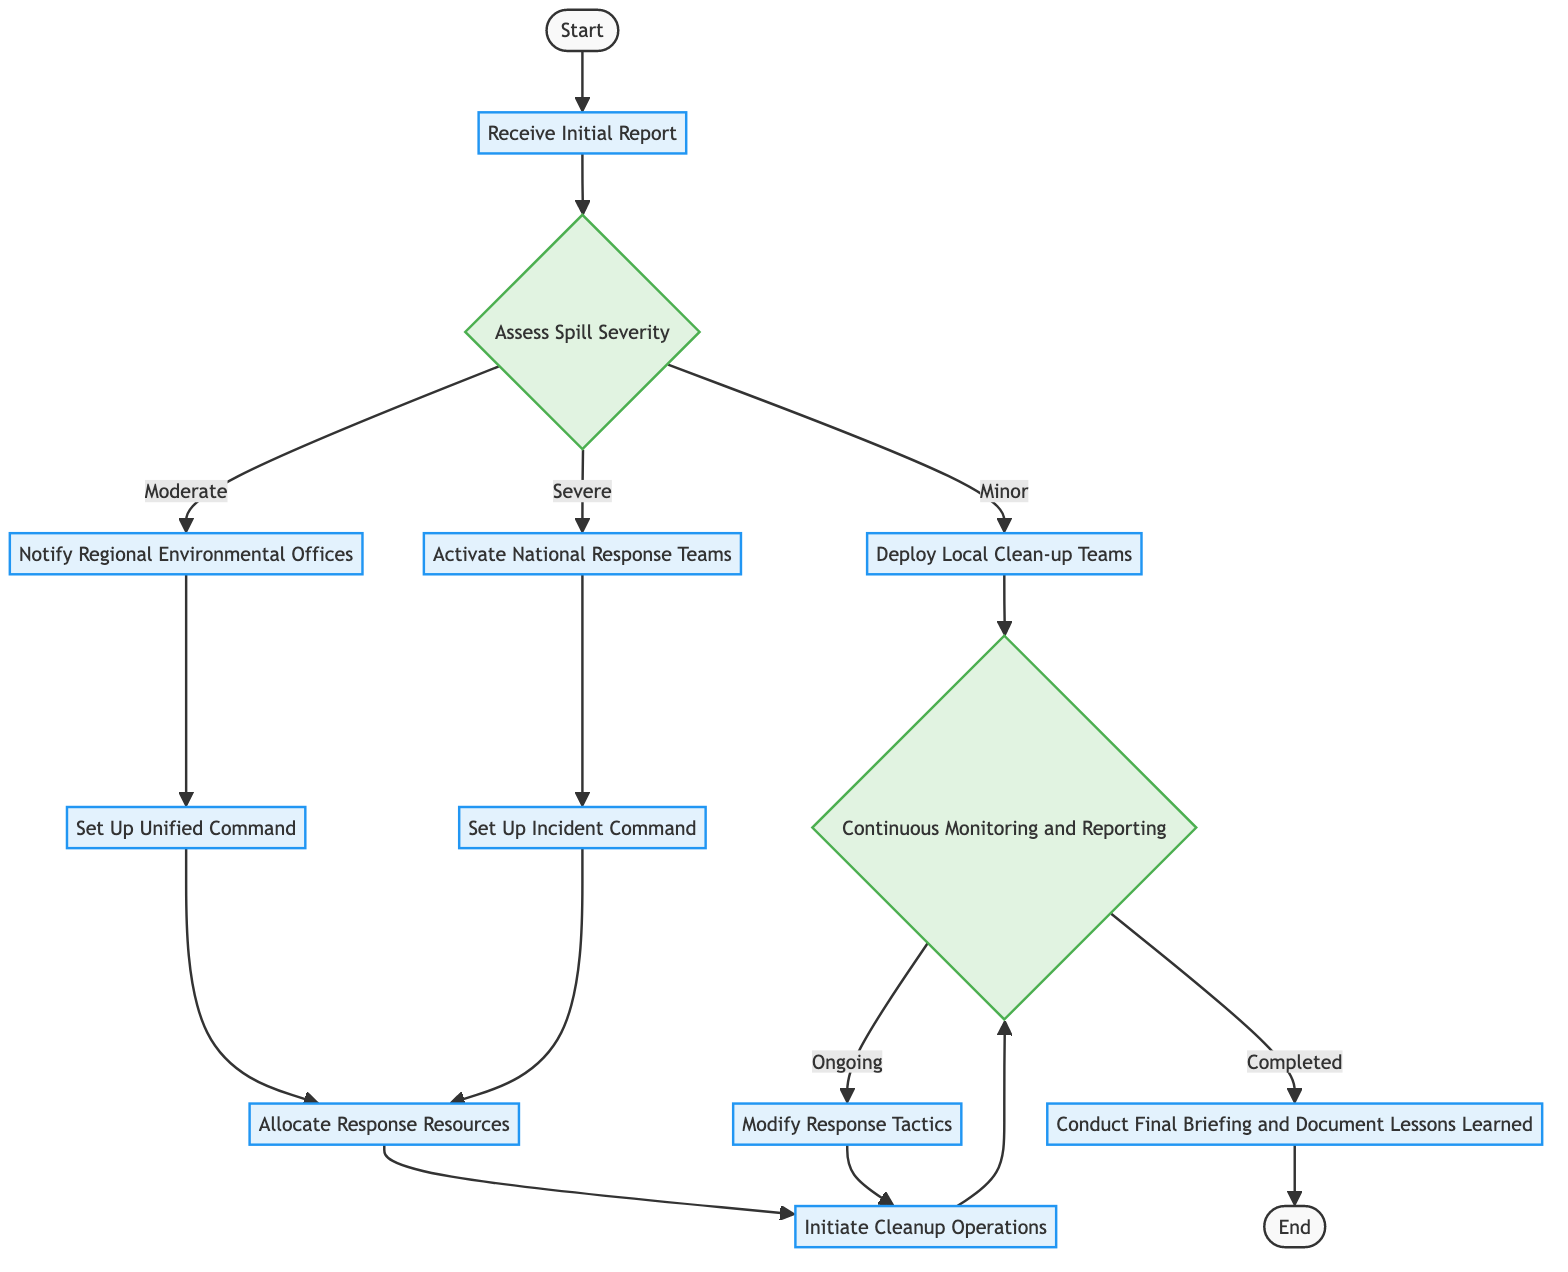What is the first step in the diagram? The diagram begins with the node labeled "Start," which is followed by the "Notification" step, indicating that the first task is to receive the initial report.
Answer: Notification How many types of spill severity are identified in the diagram? The diagram lists three specific categories of spill severity: Minor, Moderate, and Severe. This can be seen from the branching of the "Assessment" node.
Answer: 3 What is the task associated with the "Monitor and Report" node? The "Monitor and Report" node is associated with the task "Continuous Monitoring and Reporting," which is explicitly stated as the primary task in this section of the diagram.
Answer: Continuous Monitoring and Reporting What happens if the spill severity is assessed as "Severe"? If the spill severity is assessed as "Severe," the next task is to "Initiate National Response Framework," which means activating national response teams to handle the situation.
Answer: Initiate National Response Framework What leads to the "Resource Allocation" step? The "Resource Allocation" step can be reached from two prior nodes: "Coordinate Joint Operations" and "Establish Incident Command," both of which connect to this step after their respective tasks are completed.
Answer: Establish Incident Command and Coordinate Joint Operations What is the final step in the response process? The final step in the response process, as indicated in the flow, is "End," which follows the task "Conduct Final Briefing and Document Lessons Learned."
Answer: End What is the next action if the "Monitor and Report" outcome is "Ongoing"? If the outcome of "Monitor and Report" is "Ongoing," the subsequent action is to "Adjust Response Actions," which requires modifying the strategies based on the ongoing situations.
Answer: Adjust Response Actions How does the process flow from "Activate Local Responders"? After "Activate Local Responders" where local clean-up teams are deployed, the process flows to "Monitor and Report," indicating that continuous monitoring takes place after deploying the local team.
Answer: Monitor and Report What task is performed after "Allocate Response Resources"? Following the "Allocate Response Resources" task, the next task is to "Initiate Cleanup Operations," indicating that resources allocated will be used for cleanup efforts next.
Answer: Initiate Cleanup Operations 